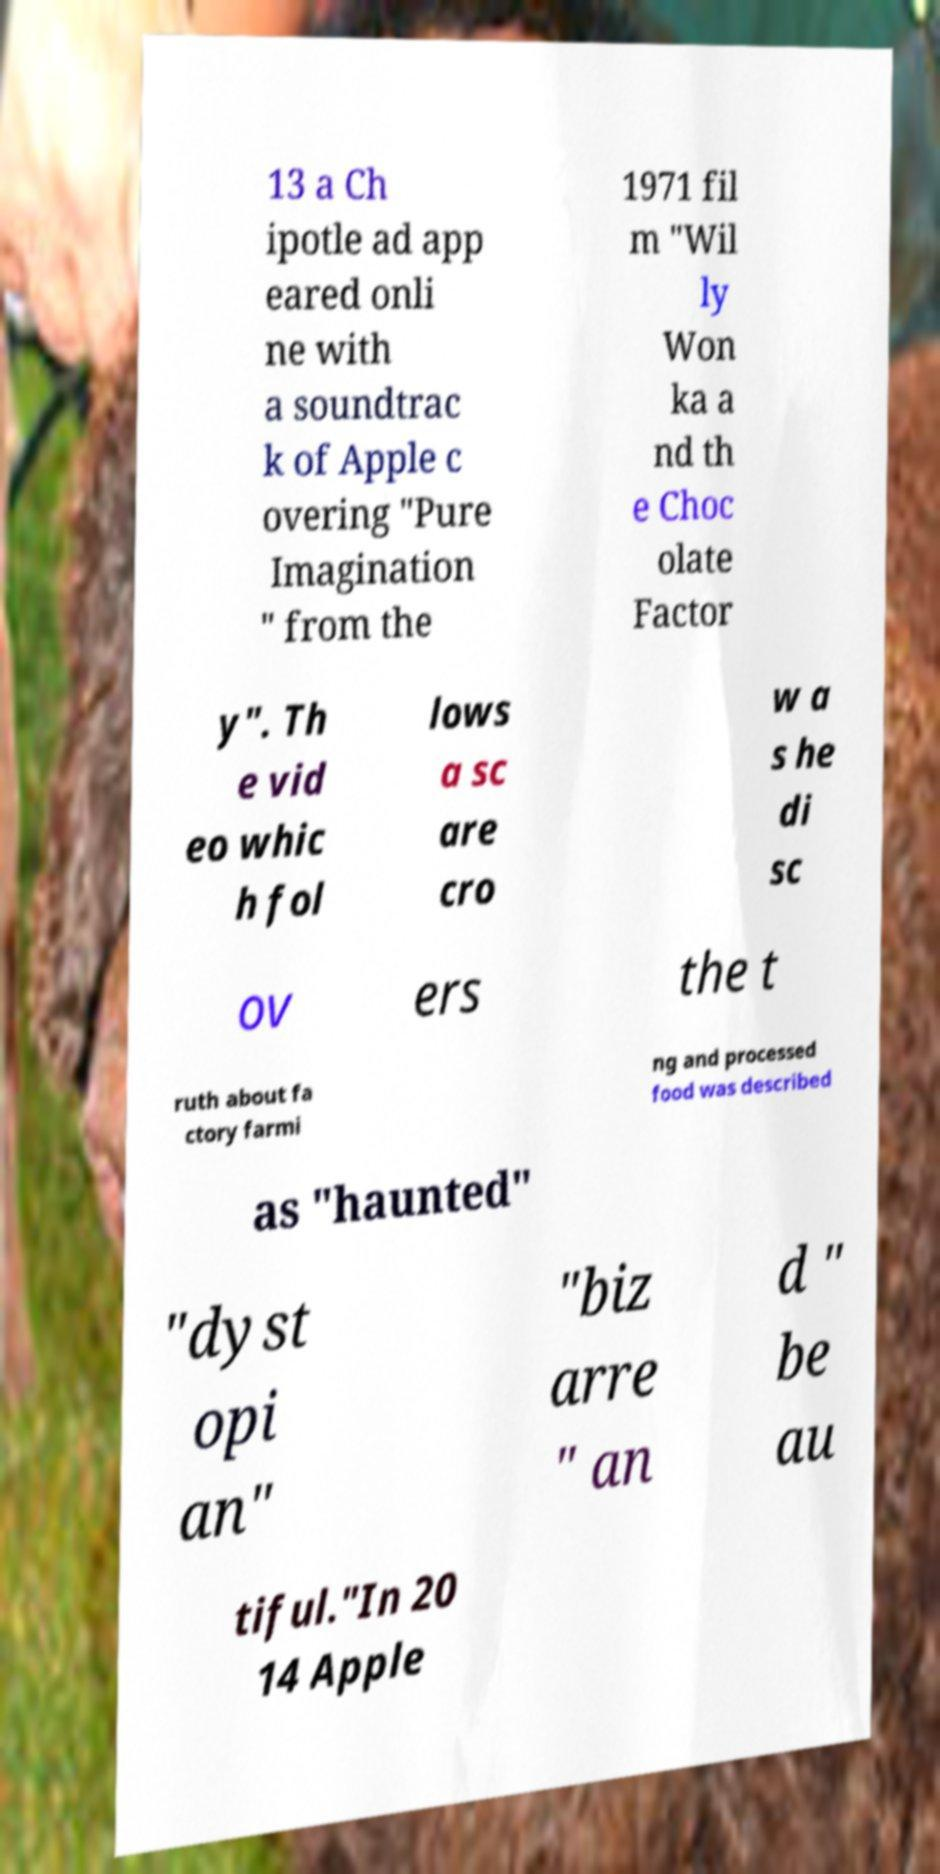I need the written content from this picture converted into text. Can you do that? 13 a Ch ipotle ad app eared onli ne with a soundtrac k of Apple c overing "Pure Imagination " from the 1971 fil m "Wil ly Won ka a nd th e Choc olate Factor y". Th e vid eo whic h fol lows a sc are cro w a s he di sc ov ers the t ruth about fa ctory farmi ng and processed food was described as "haunted" "dyst opi an" "biz arre " an d " be au tiful."In 20 14 Apple 